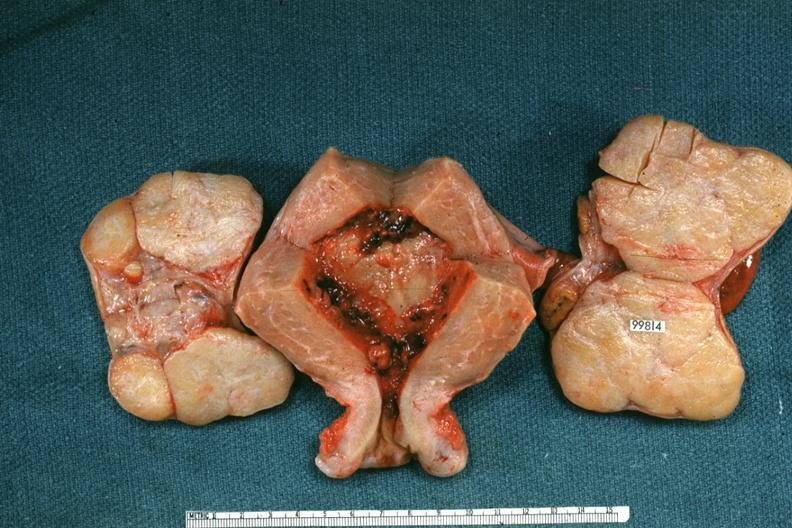does pulmonary osteoarthropathy show uterus and ovaries with bilateral brenner tumors?
Answer the question using a single word or phrase. No 